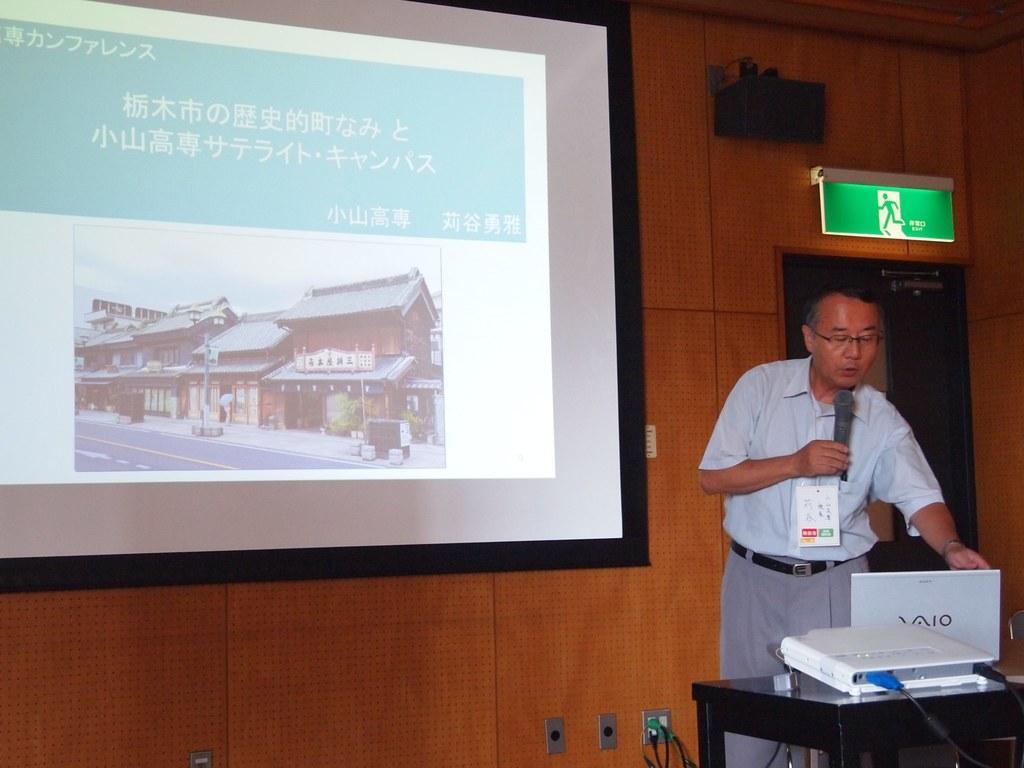Could you give a brief overview of what you see in this image? In this image person is standing behind the table having a laptop and a projector on it. Person is holding a mike in his hand. A display screen is attached to the wall having a door. There is a sound speaker and a lcd screen is attached to the wall. 